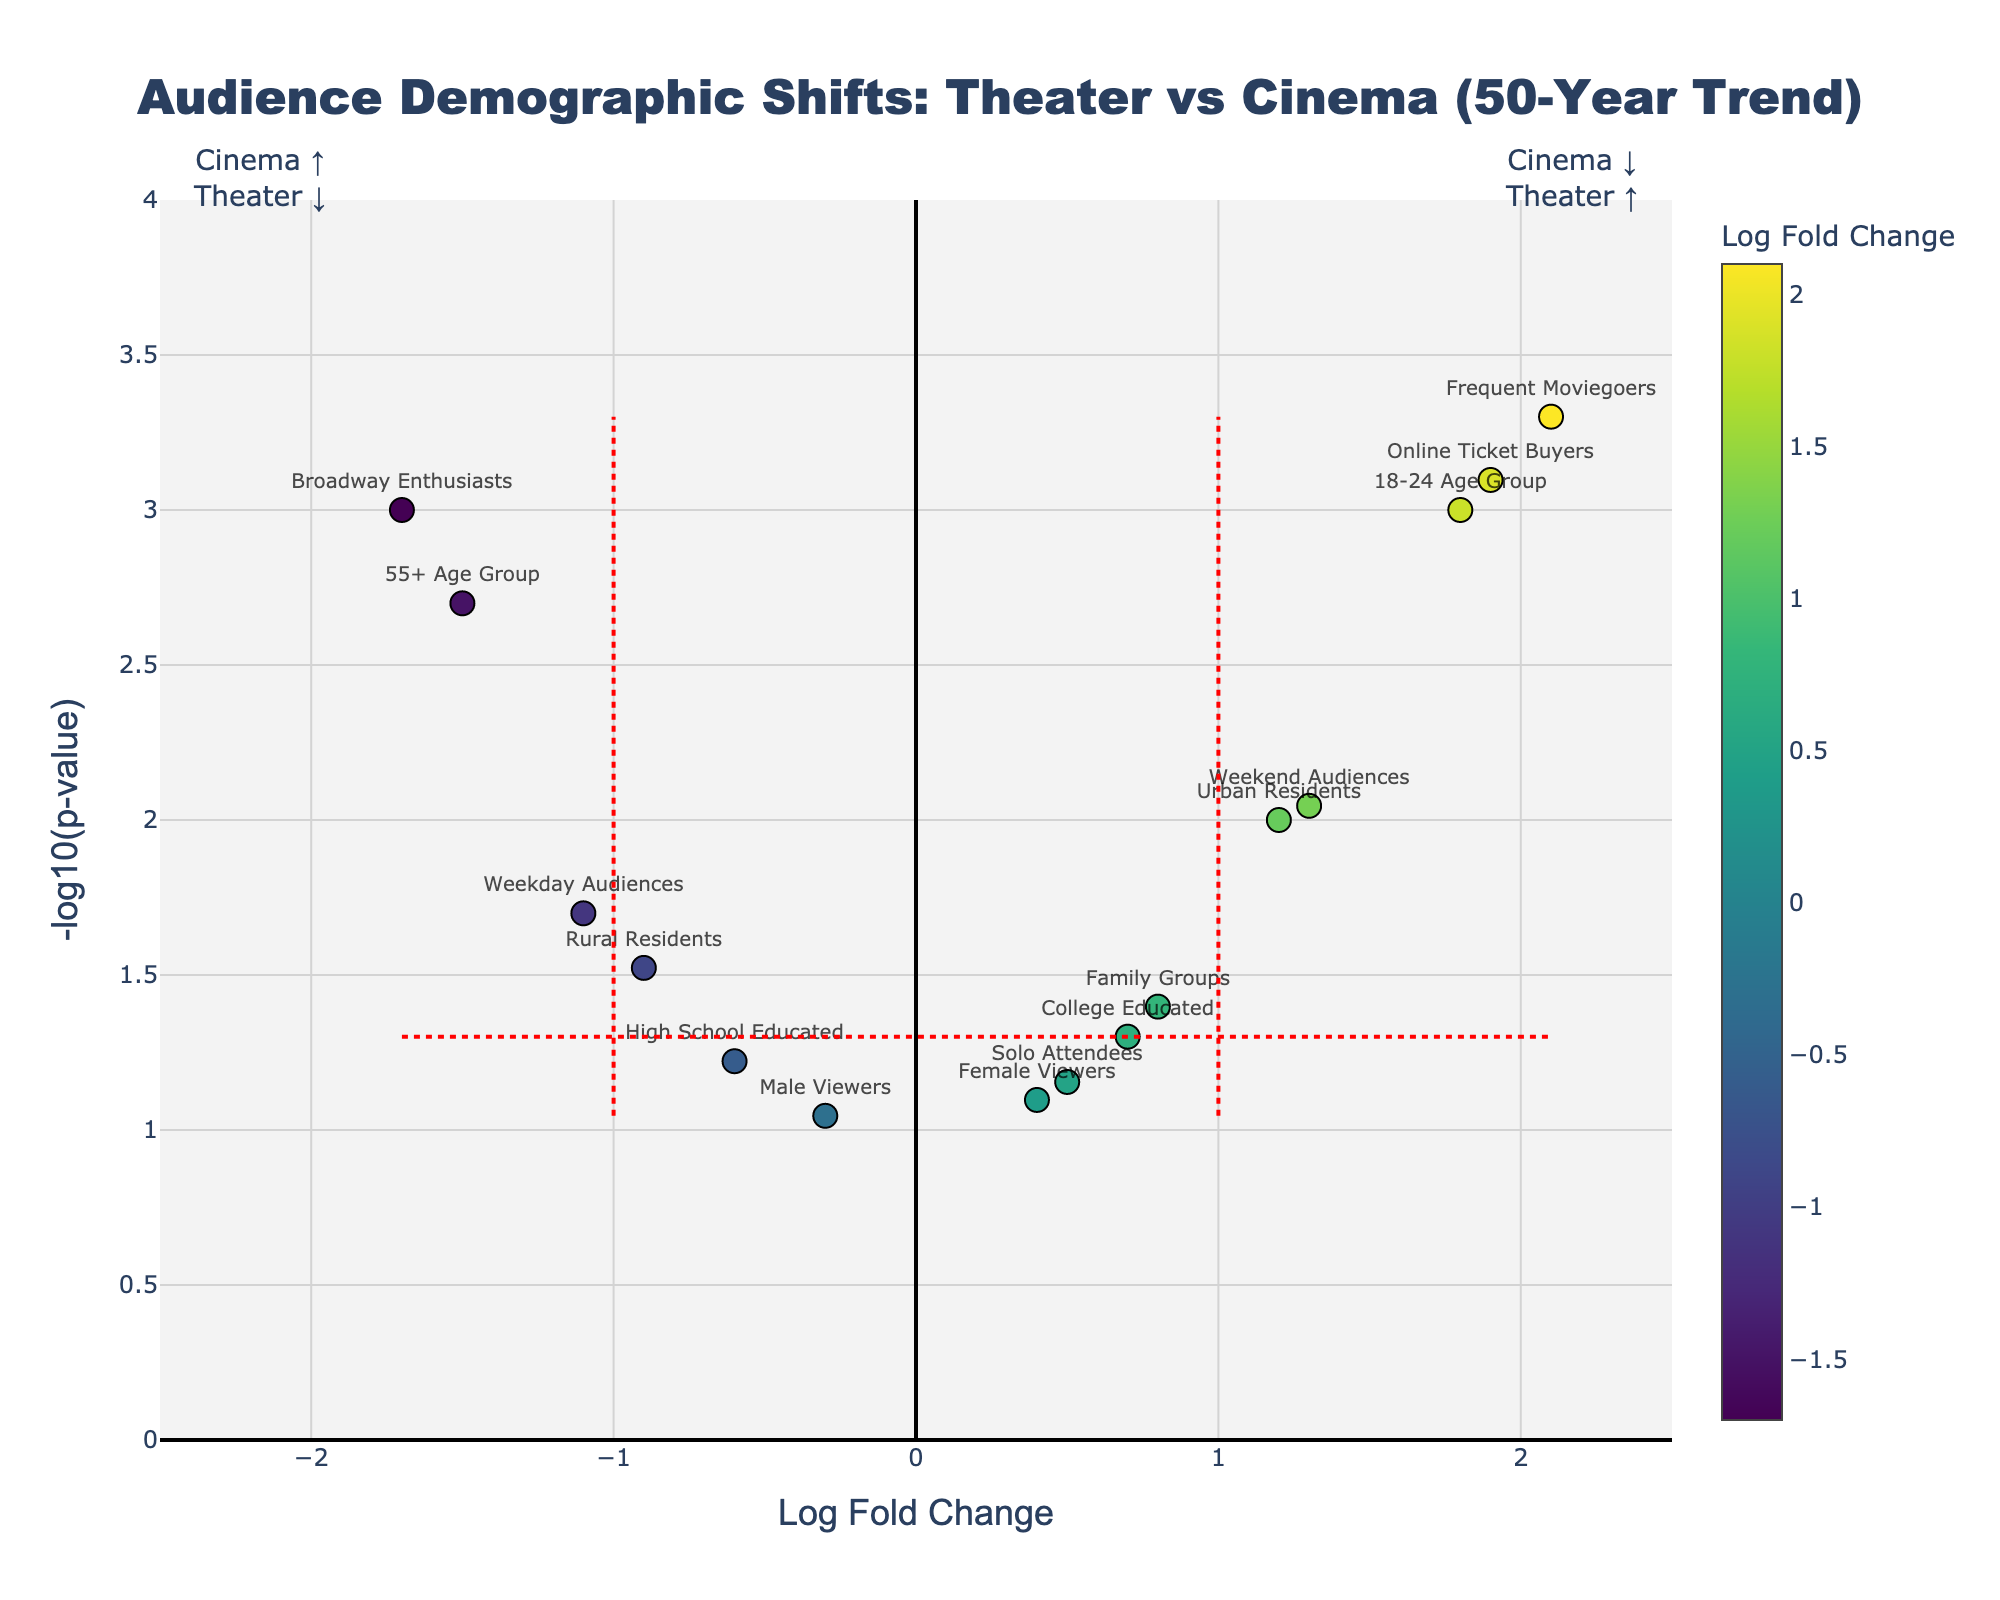What is the title of the plot? The title can be found at the top of the figure.
Answer: Audience Demographic Shifts: Theater vs Cinema (50-Year Trend) What does the x-axis represent? The x-axis label indicates what it represents.
Answer: Log Fold Change Which demographic group has the highest log fold change? Looking for the data point with the highest x-axis value.
Answer: Frequent Moviegoers How many demographic groups have a positive log fold change? Count the points with a log fold change greater than zero.
Answer: Seven What is the significance threshold in this plot? The plot includes a horizontal line to indicate the p-value threshold, often set at 0.05.
Answer: 0.05 Which group shows the most significant shift toward cinema? Identify the group with the greatest positive log fold change and the highest -log10(p-value).
Answer: Frequent Moviegoers Compare the log fold changes between Urban Residents and Rural Residents. Refer to their respective positions on the x-axis. Urban Residents have a log fold change of 1.2, and Rural Residents have -0.9.
Answer: Urban Residents > Rural Residents Which group has the least significant (highest p-value) shift observed in the plot? Identify the point with the smallest -log10(p-value).
Answer: Male Viewers Are there any demographic groups that show no significant shifts in either direction? Points within the -1 to 1 log fold change range and below the -log10(0.05) line indicate no significant shifts.
Answer: Yes, Female Viewers and Male Viewers How are weekday and weekend audience shifts different? Compare their log fold change values and positions on the figure. Weekday Audiences have a log fold change of -1.1, and Weekend Audiences have 1.3.
Answer: Weekday Audiences < Weekend Audiences 